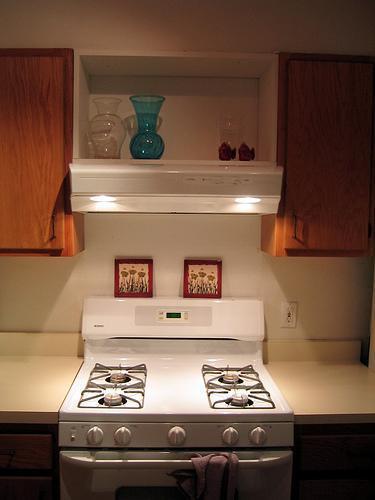How many cabinets in photo?
Give a very brief answer. 2. 